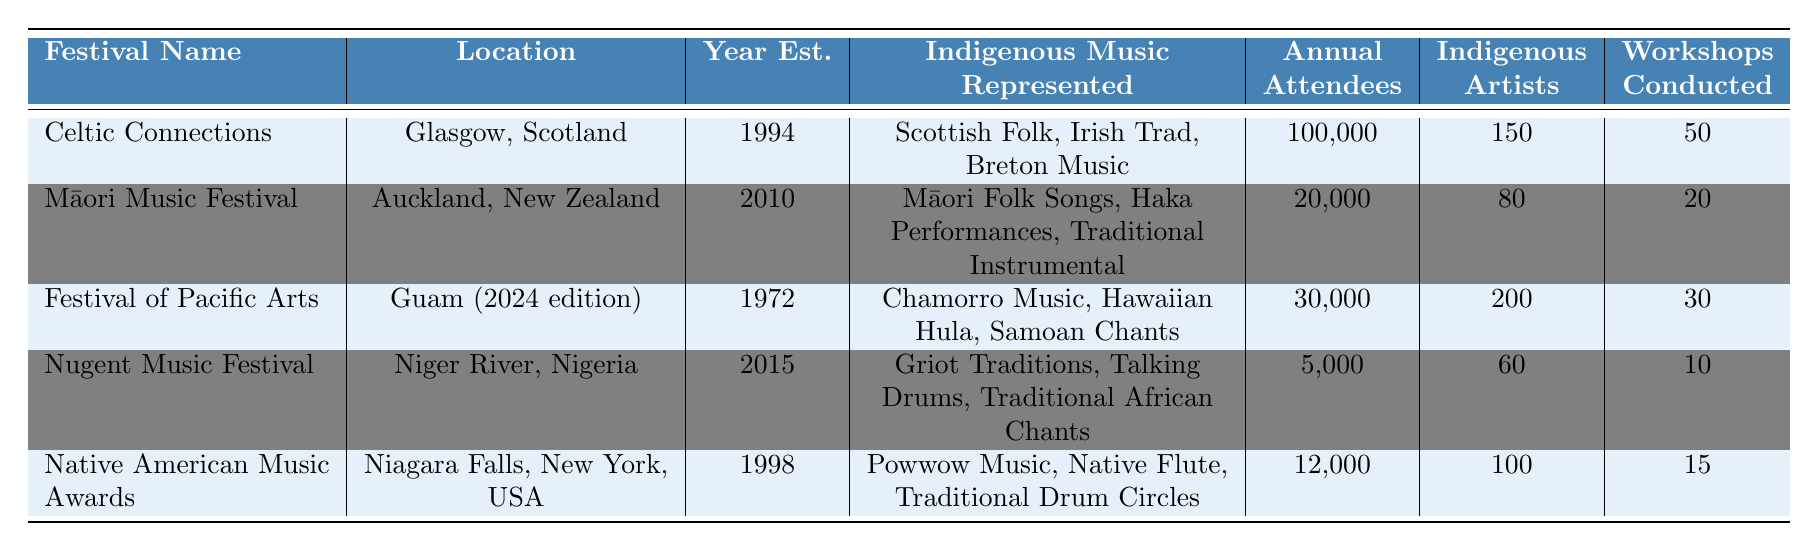What is the location of the Māori Music Festival? The table lists the location for each festival, and for the Māori Music Festival, it indicates that the location is Auckland, New Zealand.
Answer: Auckland, New Zealand Which festival has the highest number of annual attendees? By looking at the "Annual Attendees" values in the table, Celtic Connections has 100,000 attendees, which is higher than any other festival listed.
Answer: Celtic Connections How many indigenous artists featured in the Native American Music Awards? The table explicitly states that the number of indigenous artists featured in the Native American Music Awards is 100.
Answer: 100 What is the total number of workshops conducted across all festivals? To find the total number of workshops, we add the values: 50 + 20 + 30 + 10 + 15 = 125.
Answer: 125 Is Chamorro Music represented in any of the festivals? Checking the "Indigenous Music Represented" column for all the festivals, Chamorro Music is included in the Festival of Pacific Arts, confirming its representation.
Answer: Yes Which festival was established most recently? The years of establishment are listed, and Nugent Music Festival, established in 2015, is the most recent compared to the others.
Answer: Nugent Music Festival What is the average number of indigenous artists featured across all festivals? The total number of indigenous artists is 150 + 80 + 200 + 60 + 100 = 590. With 5 festivals, the average is 590 / 5 = 118.
Answer: 118 How many more annual attendees does Celtic Connections have compared to the Nugent Music Festival? Celtic Connections has 100,000 attendees and Nugent Music Festival has 5,000. The difference is 100,000 - 5,000 = 95,000.
Answer: 95,000 Which festival features the highest number of workshops conducted? The table shows that Celtic Connections conducted 50 workshops, which is the highest number compared to the other festivals.
Answer: Celtic Connections Is the Māori Music Festival older than the Native American Music Awards? The Māori Music Festival was established in 2010, and the Native American Music Awards in 1998. Since 2010 is later than 1998, it confirms that the Māori Music Festival is younger.
Answer: No 